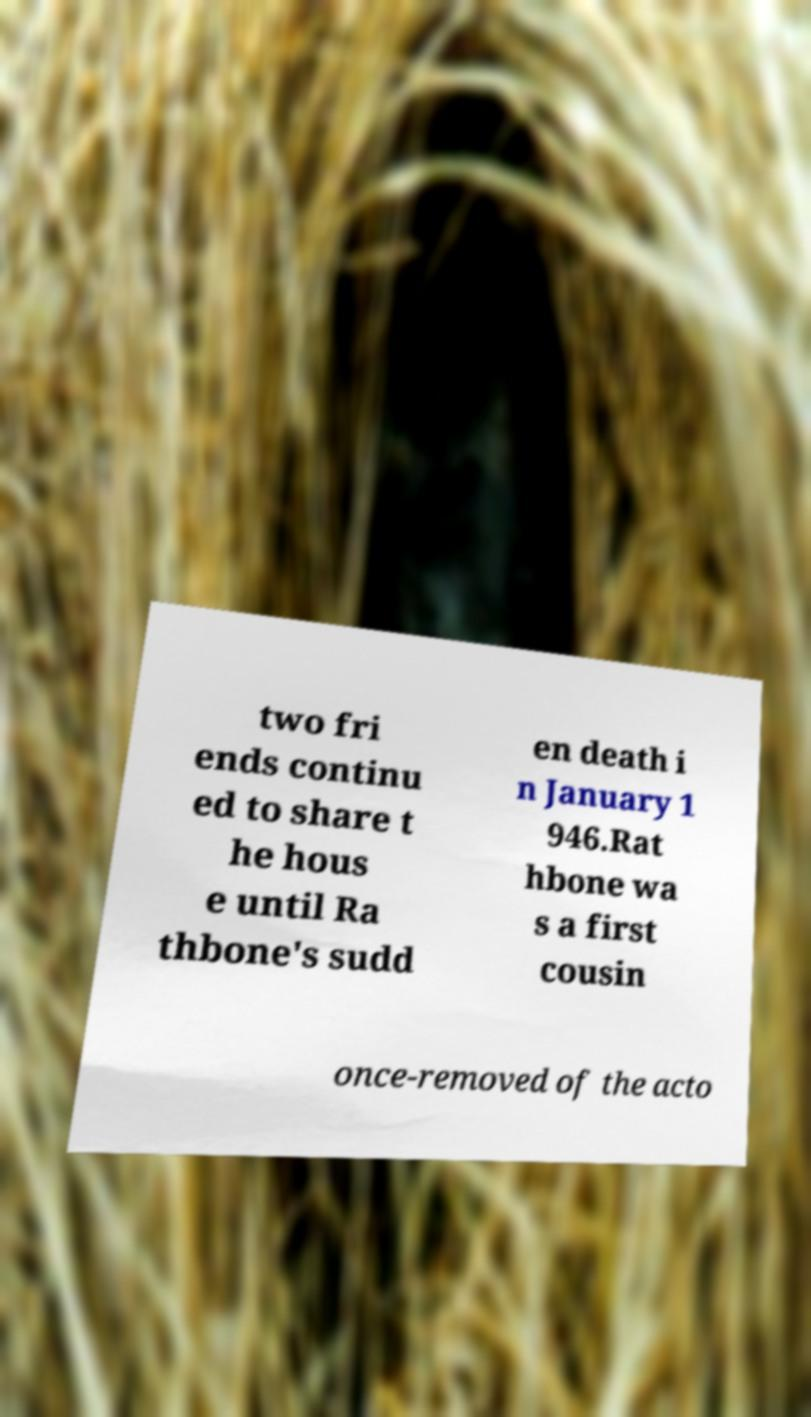I need the written content from this picture converted into text. Can you do that? two fri ends continu ed to share t he hous e until Ra thbone's sudd en death i n January 1 946.Rat hbone wa s a first cousin once-removed of the acto 